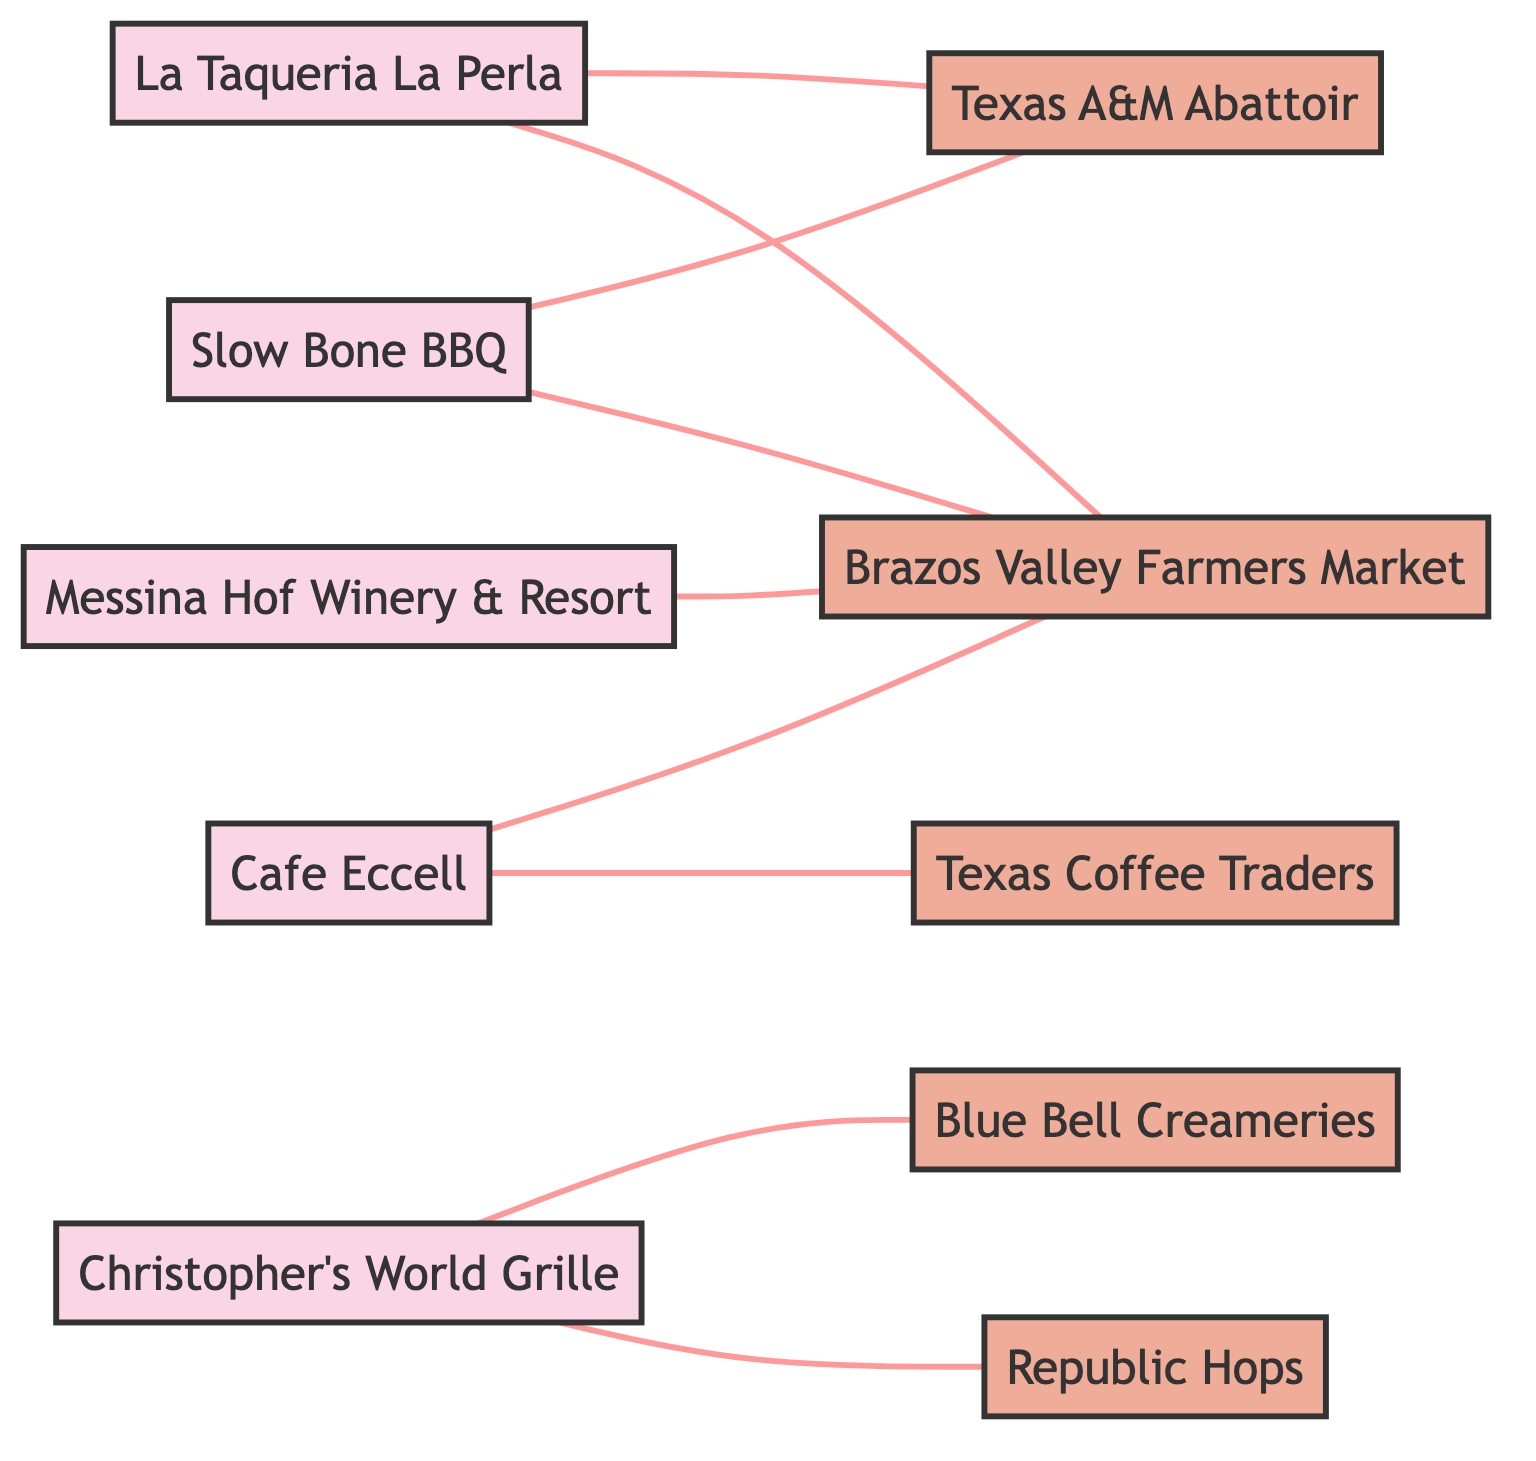What is the total number of restaurants represented in the diagram? The diagram lists five nodes that are categorized as restaurants: La Taqueria La Perla, Cafe Eccell, Christopher's World Grille, Messina Hof Winery & Resort, and Slow Bone BBQ. Counting these gives a total of five restaurants.
Answer: 5 Which supplier is connected to La Taqueria La Perla? The diagram shows two edges connected to La Taqueria La Perla. The suppliers connected are Texas A&M Abattoir and Brazos Valley Farmers Market. Therefore, the first supplier connected to it is Texas A&M Abattoir.
Answer: Texas A&M Abattoir How many edges connect to Brazos Valley Farmers Market? The diagram indicates that Brazos Valley Farmers Market is connected to four different restaurants, as indicated by the four edges linking it to La Taqueria La Perla, Cafe Eccell, Messina Hof Winery & Resort, and Slow Bone BBQ. Counting these edges yields a total of four connections.
Answer: 4 Which restaurant has the most suppliers? By examining the connections, La Taqueria La Perla and Slow Bone BBQ both connect to two suppliers each, while the others have either one or none (Cafe Eccell connects to two suppliers, Christopher's World Grille to two suppliers as well, and Messina Hof Winery & Resort to one). Hence, there are multiple restaurants with the same highest number of supplier connections, but none have more than two.
Answer: La Taqueria La Perla, Slow Bone BBQ How many unique suppliers are shown in the diagram? The diagram lists five distinct suppliers: Texas A&M Abattoir, Brazos Valley Farmers Market, Texas Coffee Traders, Blue Bell Creameries, and Republic Hops. Counting each supplier gives a total of five unique suppliers.
Answer: 5 What type of nodes has the most connections in the diagram? By analyzing the edges, the restaurants (nodes) have the most connections, as they connect to multiple suppliers. Meanwhile, each supplier connects mainly to restaurants without any connections among themselves. Thus, restaurants are more interconnected with suppliers.
Answer: Restaurants 